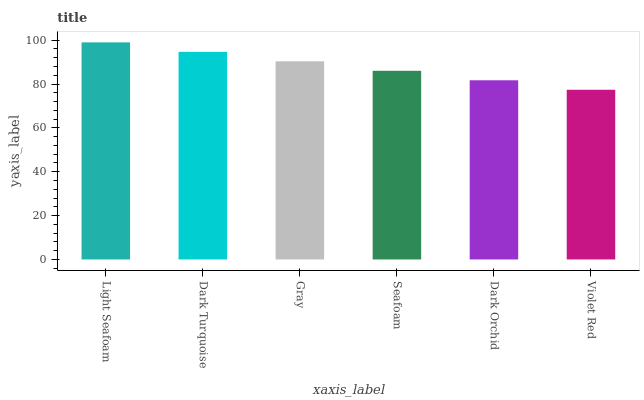Is Dark Turquoise the minimum?
Answer yes or no. No. Is Dark Turquoise the maximum?
Answer yes or no. No. Is Light Seafoam greater than Dark Turquoise?
Answer yes or no. Yes. Is Dark Turquoise less than Light Seafoam?
Answer yes or no. Yes. Is Dark Turquoise greater than Light Seafoam?
Answer yes or no. No. Is Light Seafoam less than Dark Turquoise?
Answer yes or no. No. Is Gray the high median?
Answer yes or no. Yes. Is Seafoam the low median?
Answer yes or no. Yes. Is Seafoam the high median?
Answer yes or no. No. Is Light Seafoam the low median?
Answer yes or no. No. 